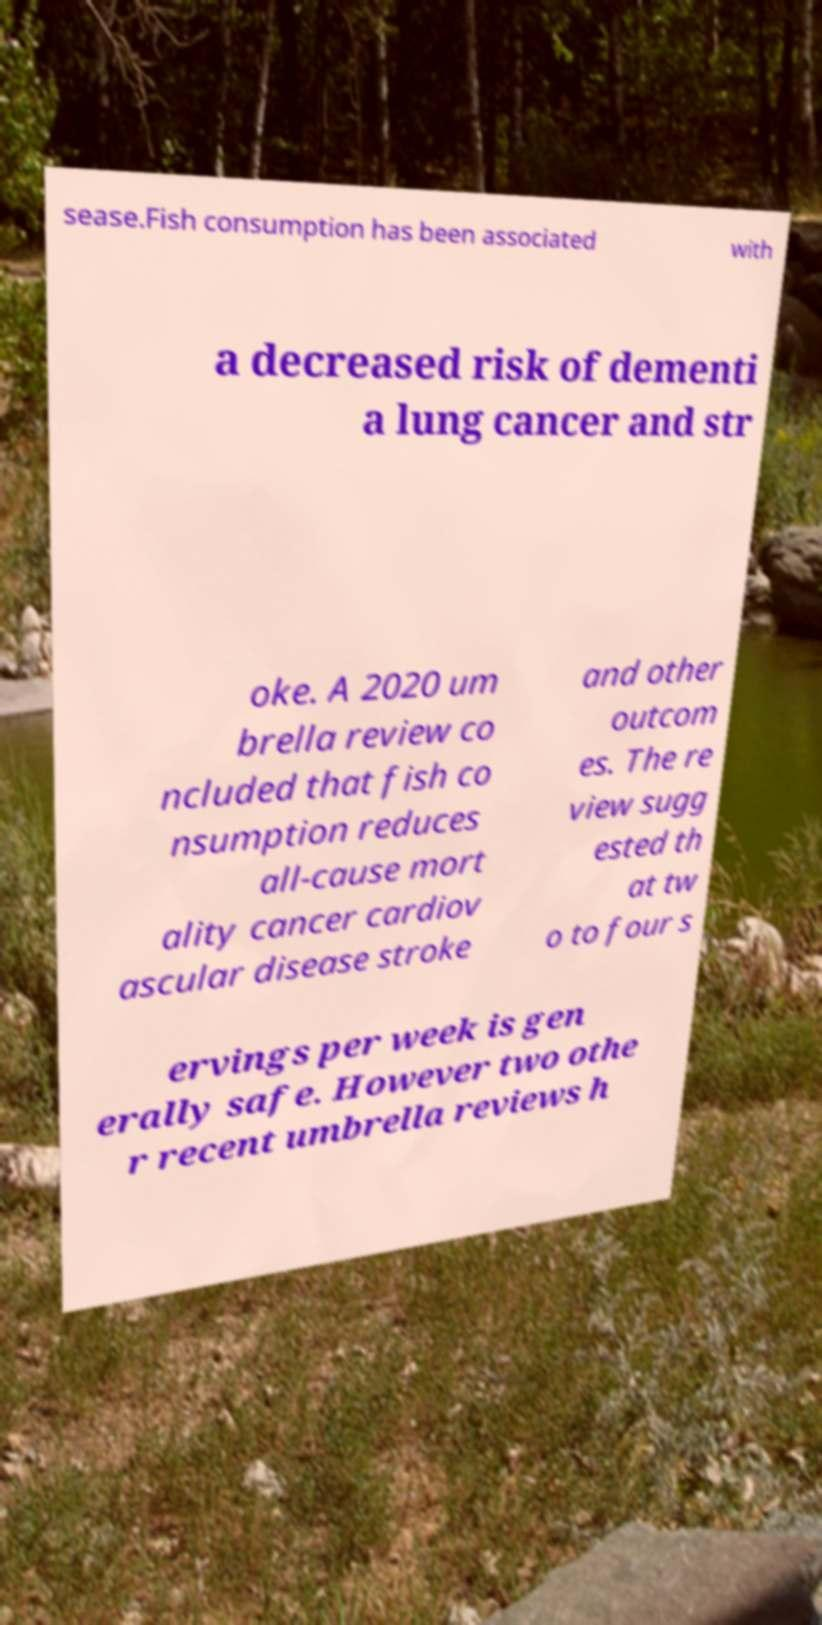Could you assist in decoding the text presented in this image and type it out clearly? sease.Fish consumption has been associated with a decreased risk of dementi a lung cancer and str oke. A 2020 um brella review co ncluded that fish co nsumption reduces all-cause mort ality cancer cardiov ascular disease stroke and other outcom es. The re view sugg ested th at tw o to four s ervings per week is gen erally safe. However two othe r recent umbrella reviews h 